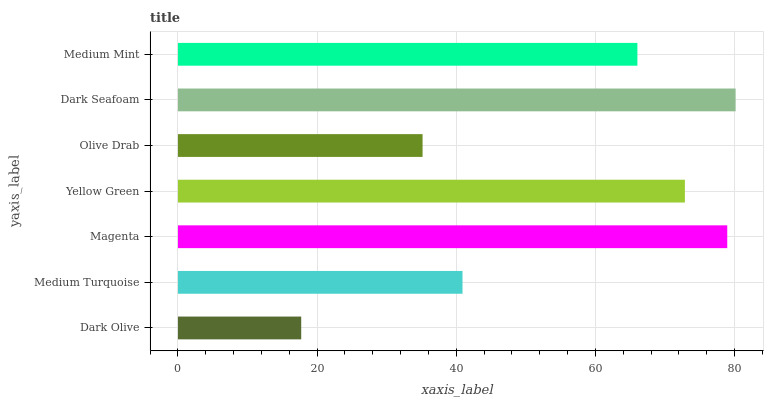Is Dark Olive the minimum?
Answer yes or no. Yes. Is Dark Seafoam the maximum?
Answer yes or no. Yes. Is Medium Turquoise the minimum?
Answer yes or no. No. Is Medium Turquoise the maximum?
Answer yes or no. No. Is Medium Turquoise greater than Dark Olive?
Answer yes or no. Yes. Is Dark Olive less than Medium Turquoise?
Answer yes or no. Yes. Is Dark Olive greater than Medium Turquoise?
Answer yes or no. No. Is Medium Turquoise less than Dark Olive?
Answer yes or no. No. Is Medium Mint the high median?
Answer yes or no. Yes. Is Medium Mint the low median?
Answer yes or no. Yes. Is Magenta the high median?
Answer yes or no. No. Is Magenta the low median?
Answer yes or no. No. 